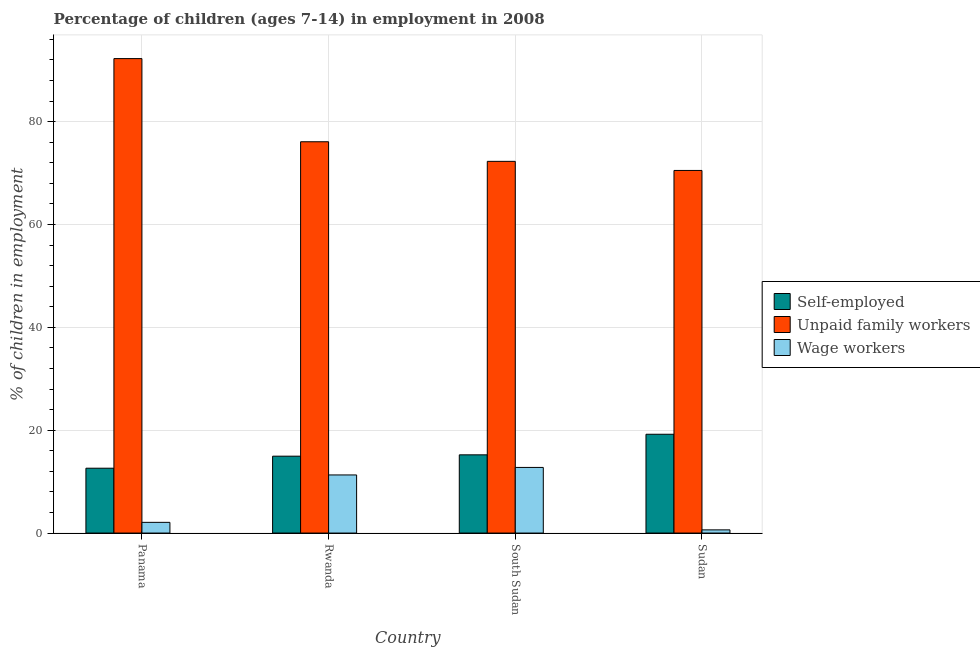Are the number of bars per tick equal to the number of legend labels?
Your answer should be very brief. Yes. How many bars are there on the 1st tick from the left?
Your answer should be very brief. 3. How many bars are there on the 4th tick from the right?
Provide a succinct answer. 3. What is the label of the 2nd group of bars from the left?
Offer a terse response. Rwanda. In how many cases, is the number of bars for a given country not equal to the number of legend labels?
Give a very brief answer. 0. What is the percentage of self employed children in Rwanda?
Ensure brevity in your answer.  14.95. Across all countries, what is the maximum percentage of self employed children?
Provide a short and direct response. 19.21. Across all countries, what is the minimum percentage of self employed children?
Your response must be concise. 12.61. In which country was the percentage of children employed as unpaid family workers maximum?
Make the answer very short. Panama. In which country was the percentage of children employed as wage workers minimum?
Your answer should be very brief. Sudan. What is the total percentage of self employed children in the graph?
Give a very brief answer. 61.98. What is the difference between the percentage of children employed as unpaid family workers in Rwanda and that in Sudan?
Provide a short and direct response. 5.58. What is the difference between the percentage of self employed children in Sudan and the percentage of children employed as unpaid family workers in Rwanda?
Keep it short and to the point. -56.88. What is the average percentage of children employed as wage workers per country?
Ensure brevity in your answer.  6.69. What is the difference between the percentage of children employed as unpaid family workers and percentage of children employed as wage workers in Rwanda?
Keep it short and to the point. 64.79. In how many countries, is the percentage of children employed as unpaid family workers greater than 44 %?
Provide a succinct answer. 4. What is the ratio of the percentage of children employed as wage workers in Panama to that in Rwanda?
Your answer should be compact. 0.18. Is the difference between the percentage of children employed as wage workers in Rwanda and Sudan greater than the difference between the percentage of self employed children in Rwanda and Sudan?
Keep it short and to the point. Yes. What is the difference between the highest and the second highest percentage of children employed as wage workers?
Your response must be concise. 1.46. What is the difference between the highest and the lowest percentage of children employed as wage workers?
Make the answer very short. 12.14. In how many countries, is the percentage of self employed children greater than the average percentage of self employed children taken over all countries?
Provide a short and direct response. 1. Is the sum of the percentage of children employed as wage workers in Rwanda and Sudan greater than the maximum percentage of children employed as unpaid family workers across all countries?
Give a very brief answer. No. What does the 2nd bar from the left in Rwanda represents?
Give a very brief answer. Unpaid family workers. What does the 1st bar from the right in Panama represents?
Your answer should be compact. Wage workers. Is it the case that in every country, the sum of the percentage of self employed children and percentage of children employed as unpaid family workers is greater than the percentage of children employed as wage workers?
Offer a very short reply. Yes. How many bars are there?
Make the answer very short. 12. How many countries are there in the graph?
Make the answer very short. 4. Does the graph contain any zero values?
Ensure brevity in your answer.  No. Where does the legend appear in the graph?
Make the answer very short. Center right. How are the legend labels stacked?
Your answer should be very brief. Vertical. What is the title of the graph?
Ensure brevity in your answer.  Percentage of children (ages 7-14) in employment in 2008. What is the label or title of the Y-axis?
Your response must be concise. % of children in employment. What is the % of children in employment of Self-employed in Panama?
Your answer should be compact. 12.61. What is the % of children in employment of Unpaid family workers in Panama?
Provide a succinct answer. 92.26. What is the % of children in employment of Wage workers in Panama?
Keep it short and to the point. 2.08. What is the % of children in employment of Self-employed in Rwanda?
Provide a short and direct response. 14.95. What is the % of children in employment of Unpaid family workers in Rwanda?
Your response must be concise. 76.09. What is the % of children in employment in Self-employed in South Sudan?
Make the answer very short. 15.21. What is the % of children in employment of Unpaid family workers in South Sudan?
Make the answer very short. 72.28. What is the % of children in employment of Wage workers in South Sudan?
Provide a short and direct response. 12.76. What is the % of children in employment in Self-employed in Sudan?
Your answer should be compact. 19.21. What is the % of children in employment of Unpaid family workers in Sudan?
Your response must be concise. 70.51. What is the % of children in employment of Wage workers in Sudan?
Make the answer very short. 0.62. Across all countries, what is the maximum % of children in employment in Self-employed?
Keep it short and to the point. 19.21. Across all countries, what is the maximum % of children in employment in Unpaid family workers?
Your response must be concise. 92.26. Across all countries, what is the maximum % of children in employment in Wage workers?
Offer a terse response. 12.76. Across all countries, what is the minimum % of children in employment of Self-employed?
Offer a terse response. 12.61. Across all countries, what is the minimum % of children in employment in Unpaid family workers?
Keep it short and to the point. 70.51. Across all countries, what is the minimum % of children in employment of Wage workers?
Keep it short and to the point. 0.62. What is the total % of children in employment in Self-employed in the graph?
Give a very brief answer. 61.98. What is the total % of children in employment in Unpaid family workers in the graph?
Give a very brief answer. 311.14. What is the total % of children in employment in Wage workers in the graph?
Your response must be concise. 26.76. What is the difference between the % of children in employment in Self-employed in Panama and that in Rwanda?
Give a very brief answer. -2.34. What is the difference between the % of children in employment of Unpaid family workers in Panama and that in Rwanda?
Your answer should be very brief. 16.17. What is the difference between the % of children in employment of Wage workers in Panama and that in Rwanda?
Offer a very short reply. -9.22. What is the difference between the % of children in employment in Self-employed in Panama and that in South Sudan?
Offer a very short reply. -2.6. What is the difference between the % of children in employment in Unpaid family workers in Panama and that in South Sudan?
Your answer should be very brief. 19.98. What is the difference between the % of children in employment of Wage workers in Panama and that in South Sudan?
Make the answer very short. -10.68. What is the difference between the % of children in employment in Self-employed in Panama and that in Sudan?
Make the answer very short. -6.6. What is the difference between the % of children in employment in Unpaid family workers in Panama and that in Sudan?
Give a very brief answer. 21.75. What is the difference between the % of children in employment of Wage workers in Panama and that in Sudan?
Your response must be concise. 1.46. What is the difference between the % of children in employment in Self-employed in Rwanda and that in South Sudan?
Keep it short and to the point. -0.26. What is the difference between the % of children in employment in Unpaid family workers in Rwanda and that in South Sudan?
Give a very brief answer. 3.81. What is the difference between the % of children in employment of Wage workers in Rwanda and that in South Sudan?
Make the answer very short. -1.46. What is the difference between the % of children in employment in Self-employed in Rwanda and that in Sudan?
Your response must be concise. -4.26. What is the difference between the % of children in employment of Unpaid family workers in Rwanda and that in Sudan?
Provide a short and direct response. 5.58. What is the difference between the % of children in employment in Wage workers in Rwanda and that in Sudan?
Your response must be concise. 10.68. What is the difference between the % of children in employment of Unpaid family workers in South Sudan and that in Sudan?
Your response must be concise. 1.77. What is the difference between the % of children in employment in Wage workers in South Sudan and that in Sudan?
Keep it short and to the point. 12.14. What is the difference between the % of children in employment of Self-employed in Panama and the % of children in employment of Unpaid family workers in Rwanda?
Keep it short and to the point. -63.48. What is the difference between the % of children in employment of Self-employed in Panama and the % of children in employment of Wage workers in Rwanda?
Your response must be concise. 1.31. What is the difference between the % of children in employment of Unpaid family workers in Panama and the % of children in employment of Wage workers in Rwanda?
Offer a very short reply. 80.96. What is the difference between the % of children in employment of Self-employed in Panama and the % of children in employment of Unpaid family workers in South Sudan?
Your answer should be very brief. -59.67. What is the difference between the % of children in employment in Unpaid family workers in Panama and the % of children in employment in Wage workers in South Sudan?
Give a very brief answer. 79.5. What is the difference between the % of children in employment of Self-employed in Panama and the % of children in employment of Unpaid family workers in Sudan?
Offer a very short reply. -57.9. What is the difference between the % of children in employment of Self-employed in Panama and the % of children in employment of Wage workers in Sudan?
Your response must be concise. 11.99. What is the difference between the % of children in employment in Unpaid family workers in Panama and the % of children in employment in Wage workers in Sudan?
Provide a short and direct response. 91.64. What is the difference between the % of children in employment of Self-employed in Rwanda and the % of children in employment of Unpaid family workers in South Sudan?
Make the answer very short. -57.33. What is the difference between the % of children in employment of Self-employed in Rwanda and the % of children in employment of Wage workers in South Sudan?
Your answer should be very brief. 2.19. What is the difference between the % of children in employment of Unpaid family workers in Rwanda and the % of children in employment of Wage workers in South Sudan?
Your response must be concise. 63.33. What is the difference between the % of children in employment in Self-employed in Rwanda and the % of children in employment in Unpaid family workers in Sudan?
Give a very brief answer. -55.56. What is the difference between the % of children in employment of Self-employed in Rwanda and the % of children in employment of Wage workers in Sudan?
Offer a very short reply. 14.33. What is the difference between the % of children in employment in Unpaid family workers in Rwanda and the % of children in employment in Wage workers in Sudan?
Keep it short and to the point. 75.47. What is the difference between the % of children in employment in Self-employed in South Sudan and the % of children in employment in Unpaid family workers in Sudan?
Your answer should be compact. -55.3. What is the difference between the % of children in employment in Self-employed in South Sudan and the % of children in employment in Wage workers in Sudan?
Offer a terse response. 14.59. What is the difference between the % of children in employment of Unpaid family workers in South Sudan and the % of children in employment of Wage workers in Sudan?
Provide a short and direct response. 71.66. What is the average % of children in employment of Self-employed per country?
Offer a very short reply. 15.49. What is the average % of children in employment of Unpaid family workers per country?
Provide a short and direct response. 77.78. What is the average % of children in employment in Wage workers per country?
Give a very brief answer. 6.69. What is the difference between the % of children in employment of Self-employed and % of children in employment of Unpaid family workers in Panama?
Provide a succinct answer. -79.65. What is the difference between the % of children in employment in Self-employed and % of children in employment in Wage workers in Panama?
Provide a short and direct response. 10.53. What is the difference between the % of children in employment in Unpaid family workers and % of children in employment in Wage workers in Panama?
Provide a succinct answer. 90.18. What is the difference between the % of children in employment of Self-employed and % of children in employment of Unpaid family workers in Rwanda?
Your answer should be very brief. -61.14. What is the difference between the % of children in employment of Self-employed and % of children in employment of Wage workers in Rwanda?
Make the answer very short. 3.65. What is the difference between the % of children in employment in Unpaid family workers and % of children in employment in Wage workers in Rwanda?
Provide a succinct answer. 64.79. What is the difference between the % of children in employment in Self-employed and % of children in employment in Unpaid family workers in South Sudan?
Your response must be concise. -57.07. What is the difference between the % of children in employment of Self-employed and % of children in employment of Wage workers in South Sudan?
Provide a succinct answer. 2.45. What is the difference between the % of children in employment in Unpaid family workers and % of children in employment in Wage workers in South Sudan?
Ensure brevity in your answer.  59.52. What is the difference between the % of children in employment in Self-employed and % of children in employment in Unpaid family workers in Sudan?
Your answer should be compact. -51.3. What is the difference between the % of children in employment of Self-employed and % of children in employment of Wage workers in Sudan?
Provide a succinct answer. 18.59. What is the difference between the % of children in employment in Unpaid family workers and % of children in employment in Wage workers in Sudan?
Give a very brief answer. 69.89. What is the ratio of the % of children in employment of Self-employed in Panama to that in Rwanda?
Give a very brief answer. 0.84. What is the ratio of the % of children in employment of Unpaid family workers in Panama to that in Rwanda?
Keep it short and to the point. 1.21. What is the ratio of the % of children in employment in Wage workers in Panama to that in Rwanda?
Offer a terse response. 0.18. What is the ratio of the % of children in employment in Self-employed in Panama to that in South Sudan?
Provide a short and direct response. 0.83. What is the ratio of the % of children in employment in Unpaid family workers in Panama to that in South Sudan?
Give a very brief answer. 1.28. What is the ratio of the % of children in employment of Wage workers in Panama to that in South Sudan?
Provide a short and direct response. 0.16. What is the ratio of the % of children in employment of Self-employed in Panama to that in Sudan?
Offer a terse response. 0.66. What is the ratio of the % of children in employment of Unpaid family workers in Panama to that in Sudan?
Make the answer very short. 1.31. What is the ratio of the % of children in employment of Wage workers in Panama to that in Sudan?
Your response must be concise. 3.35. What is the ratio of the % of children in employment of Self-employed in Rwanda to that in South Sudan?
Keep it short and to the point. 0.98. What is the ratio of the % of children in employment of Unpaid family workers in Rwanda to that in South Sudan?
Give a very brief answer. 1.05. What is the ratio of the % of children in employment of Wage workers in Rwanda to that in South Sudan?
Your answer should be very brief. 0.89. What is the ratio of the % of children in employment of Self-employed in Rwanda to that in Sudan?
Keep it short and to the point. 0.78. What is the ratio of the % of children in employment of Unpaid family workers in Rwanda to that in Sudan?
Offer a terse response. 1.08. What is the ratio of the % of children in employment in Wage workers in Rwanda to that in Sudan?
Make the answer very short. 18.23. What is the ratio of the % of children in employment in Self-employed in South Sudan to that in Sudan?
Keep it short and to the point. 0.79. What is the ratio of the % of children in employment in Unpaid family workers in South Sudan to that in Sudan?
Offer a terse response. 1.03. What is the ratio of the % of children in employment of Wage workers in South Sudan to that in Sudan?
Provide a short and direct response. 20.58. What is the difference between the highest and the second highest % of children in employment in Self-employed?
Your answer should be compact. 4. What is the difference between the highest and the second highest % of children in employment of Unpaid family workers?
Your response must be concise. 16.17. What is the difference between the highest and the second highest % of children in employment in Wage workers?
Keep it short and to the point. 1.46. What is the difference between the highest and the lowest % of children in employment of Self-employed?
Give a very brief answer. 6.6. What is the difference between the highest and the lowest % of children in employment in Unpaid family workers?
Provide a short and direct response. 21.75. What is the difference between the highest and the lowest % of children in employment in Wage workers?
Offer a terse response. 12.14. 